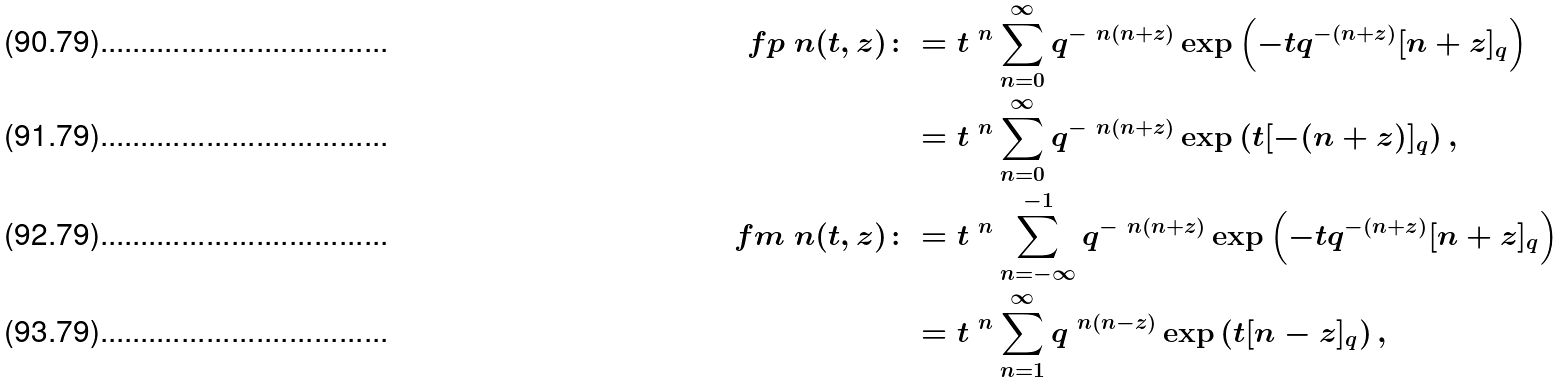Convert formula to latex. <formula><loc_0><loc_0><loc_500><loc_500>\ f p { \ n } ( t , z ) \colon & = t ^ { \ n } \sum ^ { \infty } _ { n = 0 } q ^ { - { \ n } ( n + z ) } \exp \left ( - t q ^ { - ( n + z ) } [ n + z ] _ { q } \right ) \\ & = t ^ { \ n } \sum ^ { \infty } _ { n = 0 } q ^ { - { \ n } ( n + z ) } \exp \left ( t [ - ( n + z ) ] _ { q } \right ) , \\ \ f m { \ n } ( t , z ) \colon & = t ^ { \ n } \sum ^ { - 1 } _ { n = - \infty } q ^ { - { \ n } ( n + z ) } \exp \left ( - t q ^ { - ( n + z ) } [ n + z ] _ { q } \right ) \\ & = t ^ { \ n } \sum ^ { \infty } _ { n = 1 } q ^ { { \ n } ( n - z ) } \exp \left ( t [ n - z ] _ { q } \right ) ,</formula> 